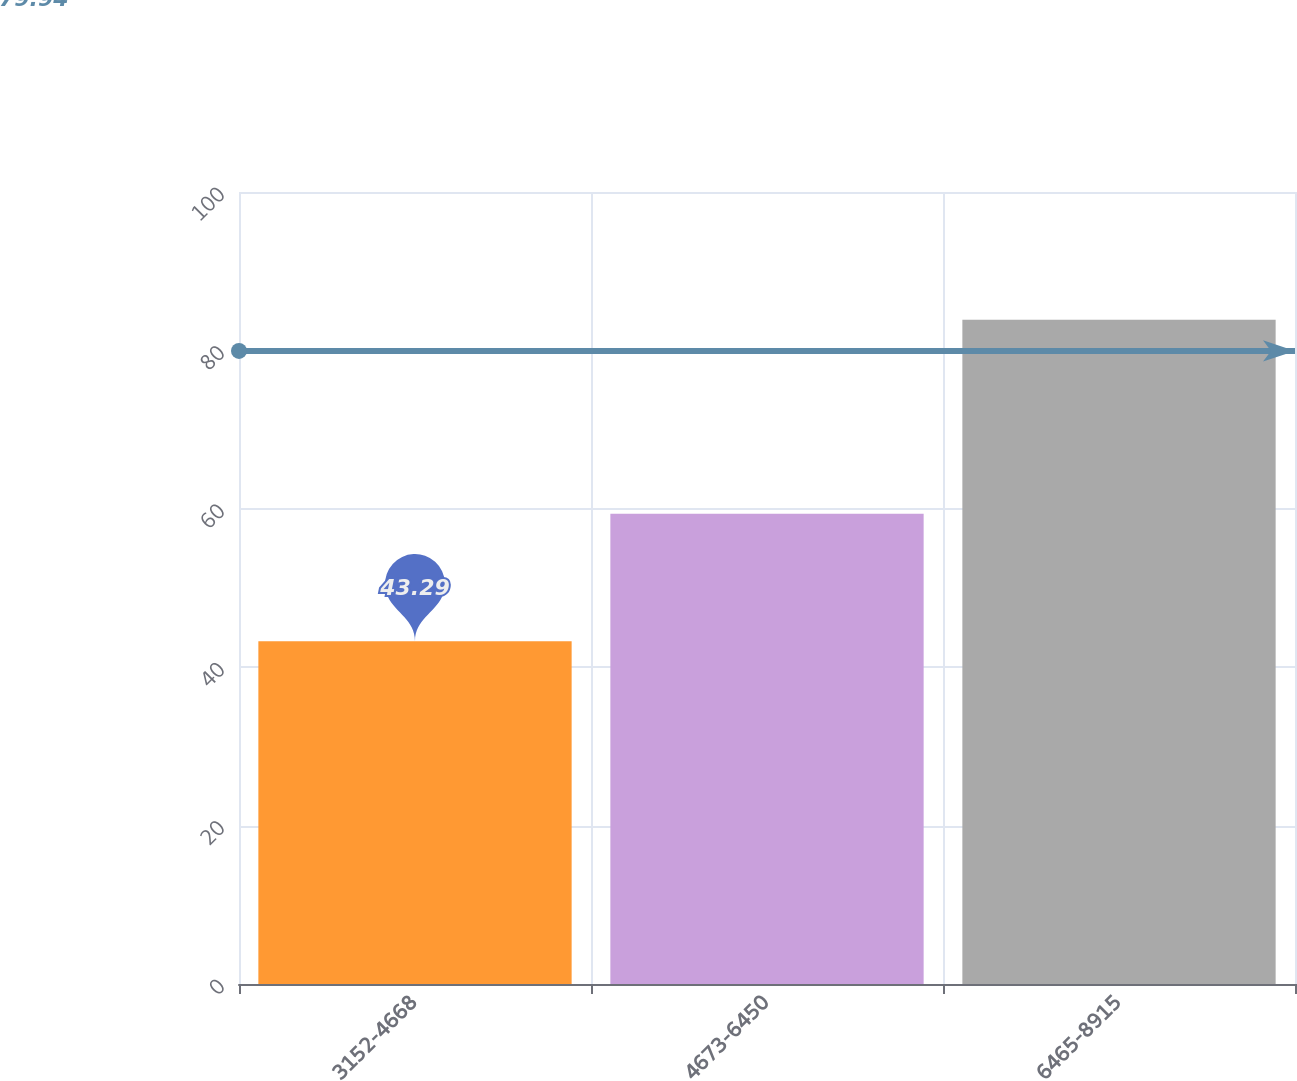<chart> <loc_0><loc_0><loc_500><loc_500><bar_chart><fcel>3152-4668<fcel>4673-6450<fcel>6465-8915<nl><fcel>43.29<fcel>59.37<fcel>83.86<nl></chart> 